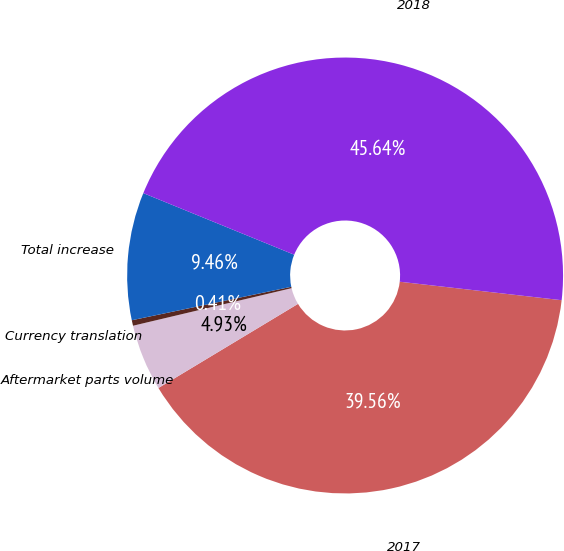Convert chart to OTSL. <chart><loc_0><loc_0><loc_500><loc_500><pie_chart><fcel>2017<fcel>Aftermarket parts volume<fcel>Currency translation<fcel>Total increase<fcel>2018<nl><fcel>39.56%<fcel>4.93%<fcel>0.41%<fcel>9.46%<fcel>45.64%<nl></chart> 